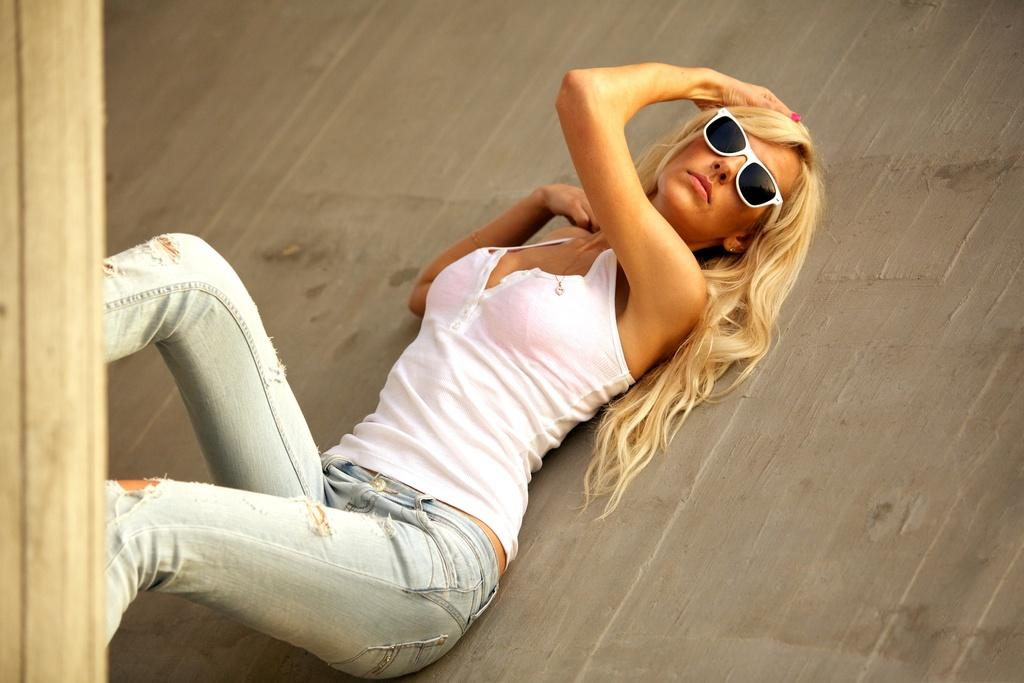Who is the main subject in the image? There is a woman in the image. What is the woman wearing on her upper body? The woman is wearing a white top. What is the woman wearing on her lower body? The woman is wearing blue jeans. What can be seen on the right side of the image? There is a wall on the right side of the image. What object is present on the left side of the image? There is a wooden stick on the left side of the image. What type of eyewear is the woman wearing? The woman is wearing shades. What type of plane can be seen flying in the image? There is no plane visible in the image. What is the woman using to carry water in the image? There is no pail or any object for carrying water present in the image. 